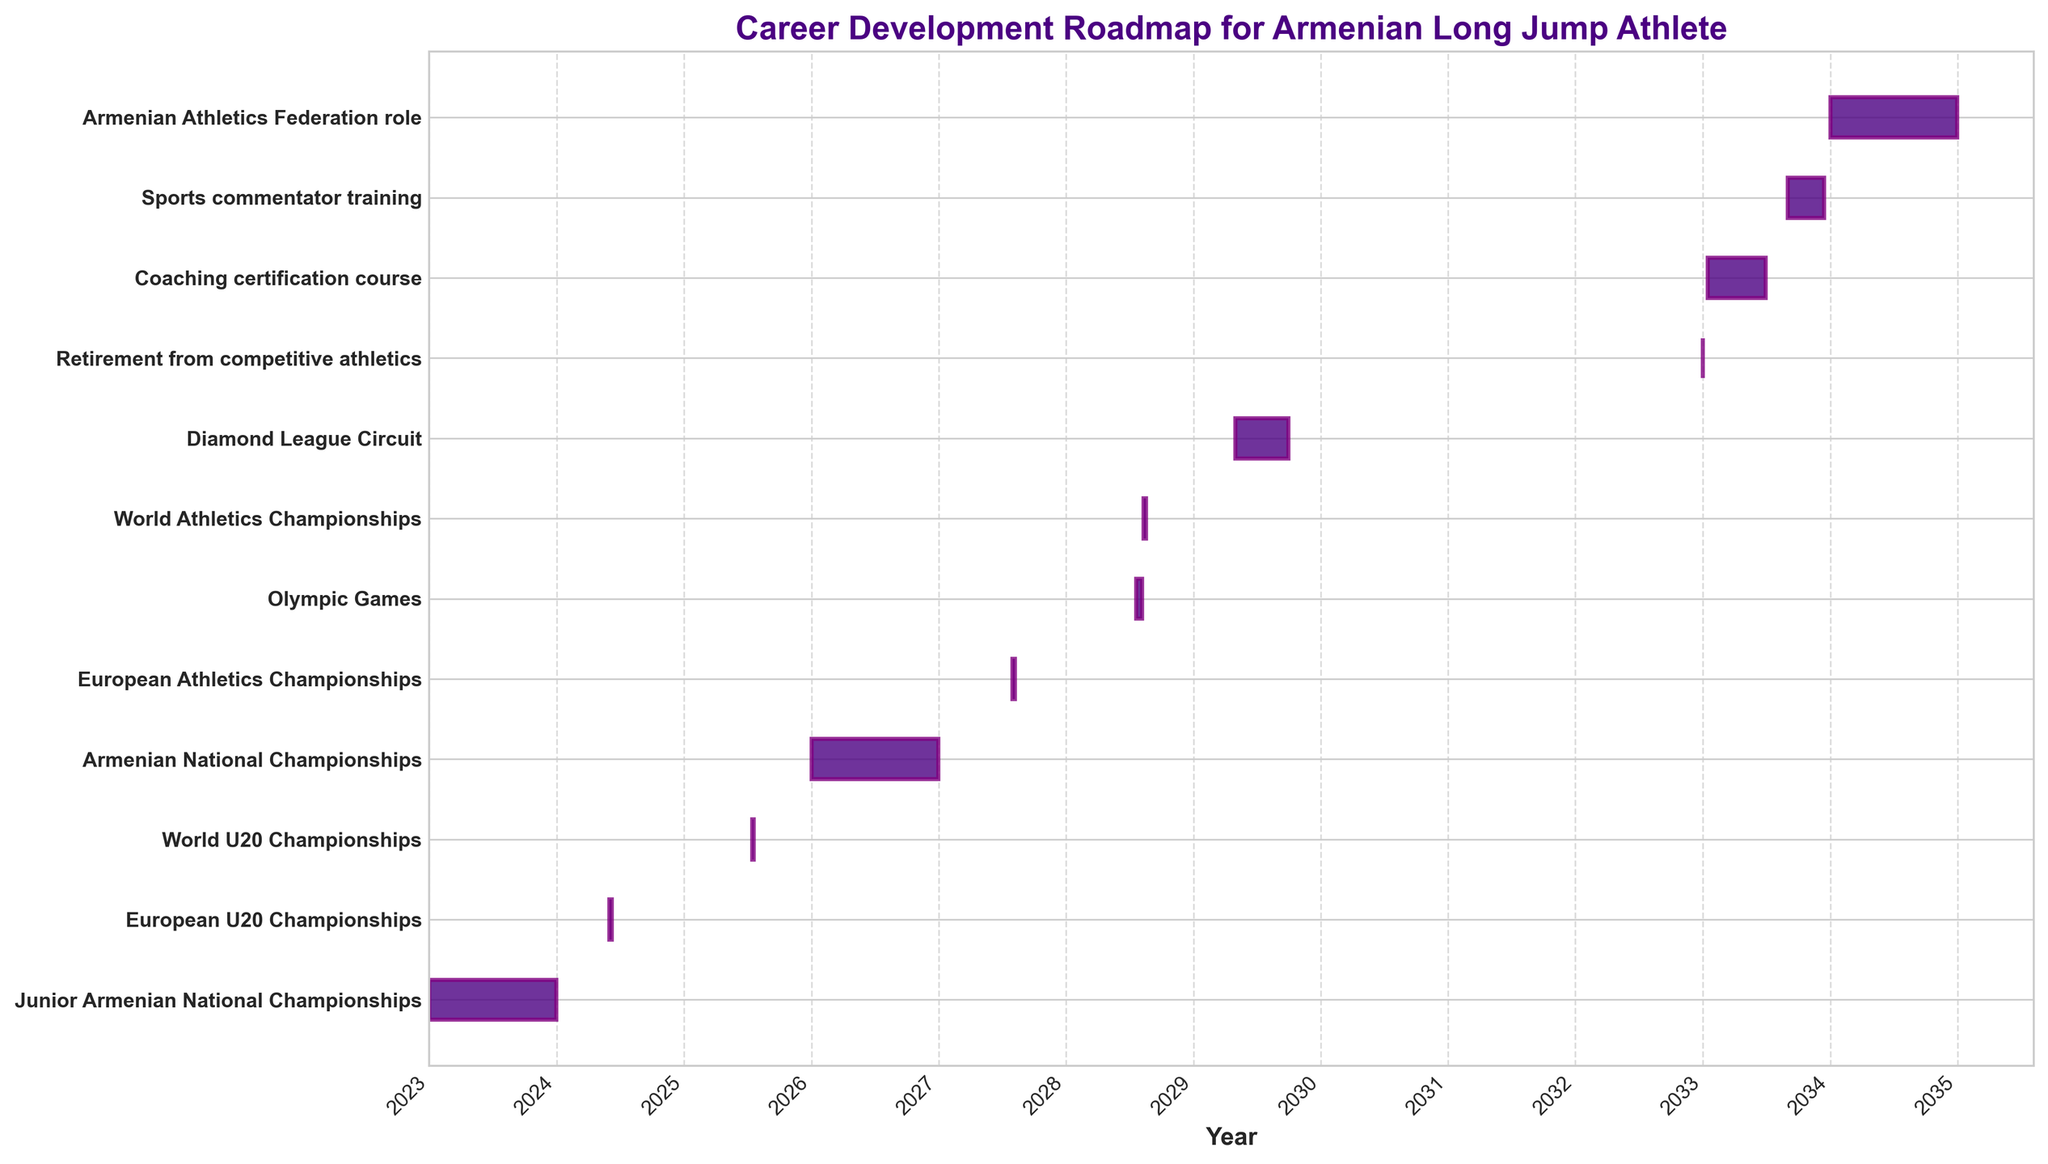What is the title of the figure? The title is usually at the top of the figure indicated in larger and bold text. It typically describes what the figure represents.
Answer: Career Development Roadmap for Armenian Long Jump Athlete What is the timeframe for the European U20 Championships? Look for the bar labeled "European U20 Championships" and check the start and end dates written alongside.
Answer: June 1, 2024, to June 7, 2024 Which event lasts the longest within the competitive athletics timeline? Compare the durations of all events before the "Retirement from competitive athletics" bar by measuring the length of each bar from start to end.
Answer: Armenian National Championships (2026) How many years apart are the European Athletics Championships and the Olympic Games? Find the start dates of both "European Athletics Championships" and "Olympic Games," then calculate the difference in years.
Answer: 1 year What event occurs immediately after the World Athletics Championships? Identify the position of the "World Athletics Championships" bar and find the nearest subsequent bar in terms of start date.
Answer: Diamond League Circuit Is the coaching certification course completed before the sports commentator training begins? Check the end date of "Coaching certification course" and the start date of "Sports commentator training" to see if they overlap or follow sequentially.
Answer: Yes Which post-athletic career transition starts first? Look for the first occurrence of any post-competitive athletic event by checking the order of bars after "Retirement from competitive athletics."
Answer: Coaching certification course How long is the Diamond League Circuit? Calculate the difference in length from the start date to the end date of the "Diamond League Circuit" bar.
Answer: Approximately 5 months Within how many years does the transition from competitive athletics to a role in the Armenian Athletics Federation occur? Find the end date of "Retirement from competitive athletics" and the start date of "Armenian Athletics Federation role" and calculate the difference in years.
Answer: 1 year Which competitions occur in 2028? Identify any bars that are within the year 2028 by checking their start and end dates.
Answer: World Athletics Championships and Olympic Games 